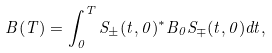<formula> <loc_0><loc_0><loc_500><loc_500>B ( T ) = \int _ { 0 } ^ { T } S _ { \pm } ( t , 0 ) ^ { * } B _ { 0 } S _ { \mp } ( t , 0 ) d t ,</formula> 